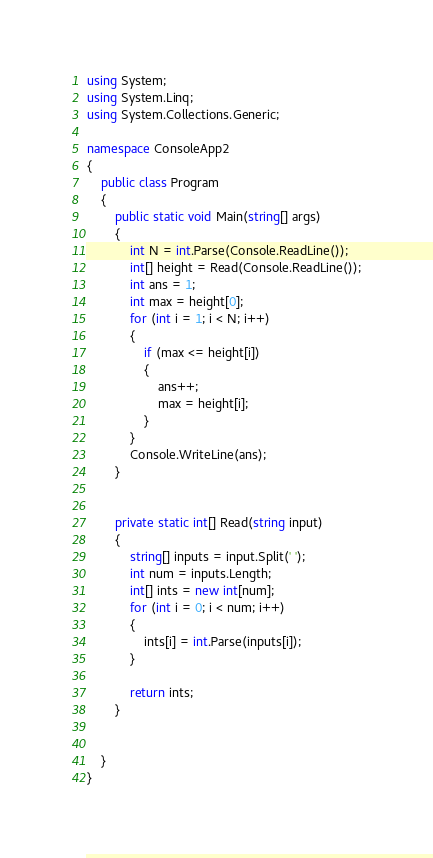<code> <loc_0><loc_0><loc_500><loc_500><_C#_>using System;
using System.Linq;
using System.Collections.Generic;

namespace ConsoleApp2
{
    public class Program
    {
        public static void Main(string[] args)
        {
            int N = int.Parse(Console.ReadLine());
            int[] height = Read(Console.ReadLine());
            int ans = 1;
            int max = height[0];
            for (int i = 1; i < N; i++)
            {
                if (max <= height[i])
                {
                    ans++;
                    max = height[i];
                }
            }
            Console.WriteLine(ans);
        }


        private static int[] Read(string input)
        {
            string[] inputs = input.Split(' ');
            int num = inputs.Length;
            int[] ints = new int[num];
            for (int i = 0; i < num; i++)
            {
                ints[i] = int.Parse(inputs[i]);
            }
            
            return ints;
        }


    }
}
</code> 